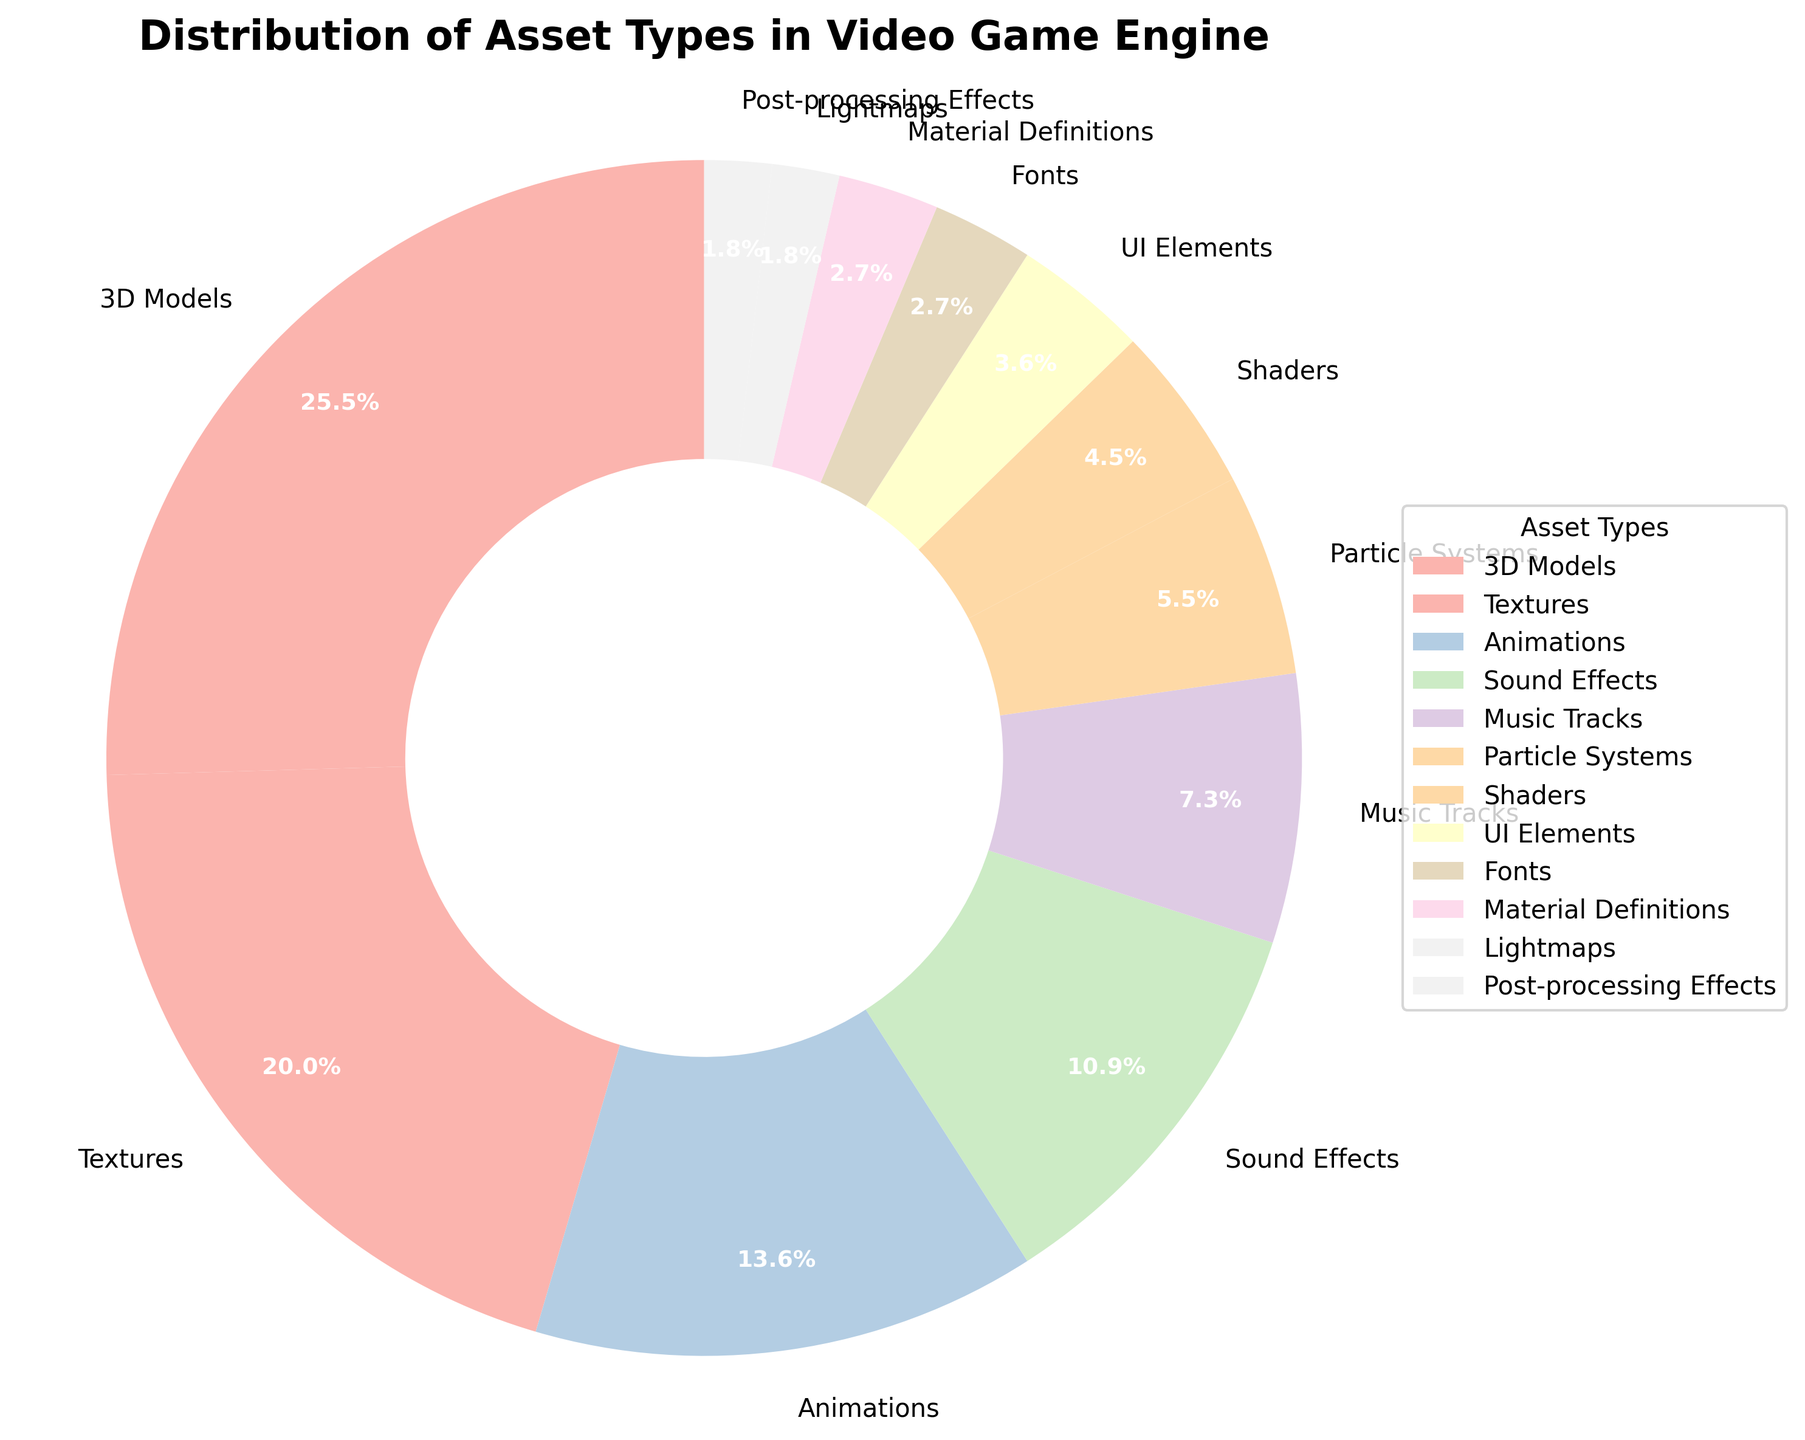Which asset type has the largest percentage? The percentage next to each asset type shows that "3D Models" has the largest percentage at 28%.
Answer: 3D Models What's the combined percentage of Sound Effects and Music Tracks? The percentage for Sound Effects is 12%, and for Music Tracks, it's 8%. Adding them together, 12% + 8% = 20%.
Answer: 20% Which asset type has a larger percentage, Fonts or Material Definitions? The pie chart shows that both Fonts and Material Definitions have a percentage of 3%. Therefore, neither is larger.
Answer: They are equal How does the percentage of Textures compare to that of Animations? From the chart, Textures have 22% while Animations have 15%. Comparing these, Textures have a larger percentage than Animations.
Answer: Textures are larger Which asset types have a percentage smaller than Post-processing Effects? The figure lists Post-processing Effects at 2%. The asset types with a smaller percentage are none, as all other listed percentages are equal to or larger than 2%.
Answer: None If we sum the percentages of 3D Models, Textures, and Animations, what do we get? The percentages are 3D Models (28%), Textures (22%), and Animations (15%). Adding these, 28% + 22% + 15% = 65%.
Answer: 65% What is the difference in percentage between UI Elements and Shaders? The percentages for UI Elements and Shaders are 4% and 5% respectively. Subtracting these, 5% - 4% = 1%.
Answer: 1% Are Particle Systems or Music Tracks represented by a smaller percentage? The percentage for Particle Systems is 6%, and for Music Tracks, it's 8%. Therefore, Particle Systems have a smaller percentage.
Answer: Particle Systems Which asset type shows the smallest percentage, and what is it? From the chart, the asset types with the smallest percentage are Lightmaps and Post-processing Effects, both at 2%.
Answer: Lightmaps and Post-processing Effects How many asset types have a percentage of 3%? The pie chart shows that fonts and material definitions both have a percentage of 3%. That makes 2 asset types with a percentage of 3%.
Answer: 2 